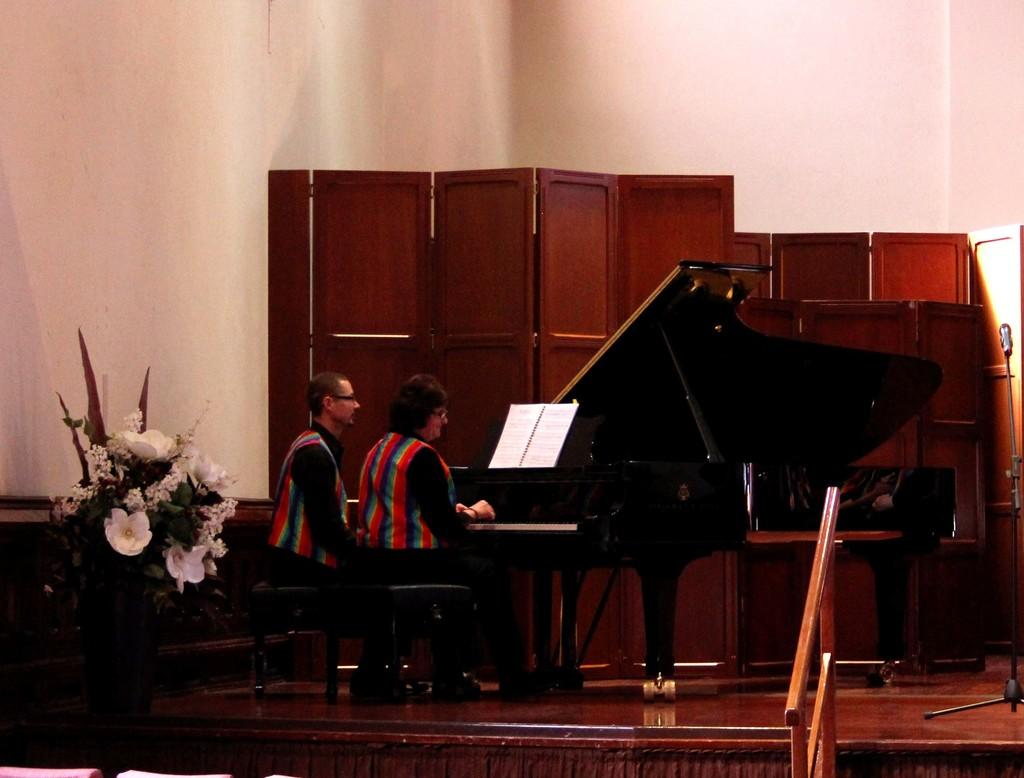What is the main object in the middle of the image? There is a piano in the middle of the image. What is the woman in the image doing? The woman is playing the keyboard on the piano. What is the man in the image doing? The man is sitting and staring at the piano. What can be seen on the left side of the image? There is a flower vase on the left side of the image. Can you tell me how many volcanoes are visible in the image? There are no volcanoes present in the image; it features a piano, a woman playing it, a man observing it, and a flower vase. Is there an island in the background of the image? There is no island visible in the image; it is focused on the piano, the people, and the flower vase. 